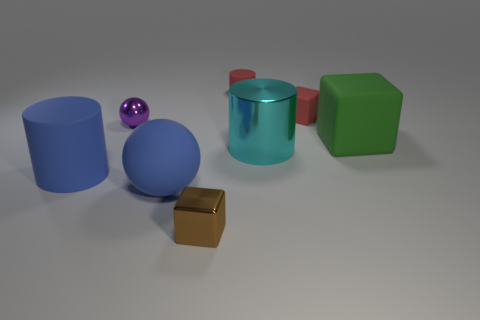What number of other things are the same size as the green matte thing?
Ensure brevity in your answer.  3. Are there any red matte things behind the tiny red rubber cylinder?
Ensure brevity in your answer.  No. There is a large ball; is it the same color as the big cylinder on the left side of the tiny brown metallic thing?
Offer a terse response. Yes. There is a small block that is on the left side of the rubber cylinder that is right of the sphere that is behind the large green matte thing; what color is it?
Keep it short and to the point. Brown. Is there another metal object that has the same shape as the small brown shiny object?
Keep it short and to the point. No. What color is the sphere that is the same size as the cyan cylinder?
Your answer should be compact. Blue. There is a cylinder behind the big green object; what is it made of?
Offer a very short reply. Rubber. There is a brown metallic thing to the right of the big blue sphere; is it the same shape as the large rubber thing right of the brown metal cube?
Your answer should be very brief. Yes. Are there an equal number of matte cubes that are in front of the large green object and spheres?
Give a very brief answer. No. What number of cylinders have the same material as the big green cube?
Offer a terse response. 2. 